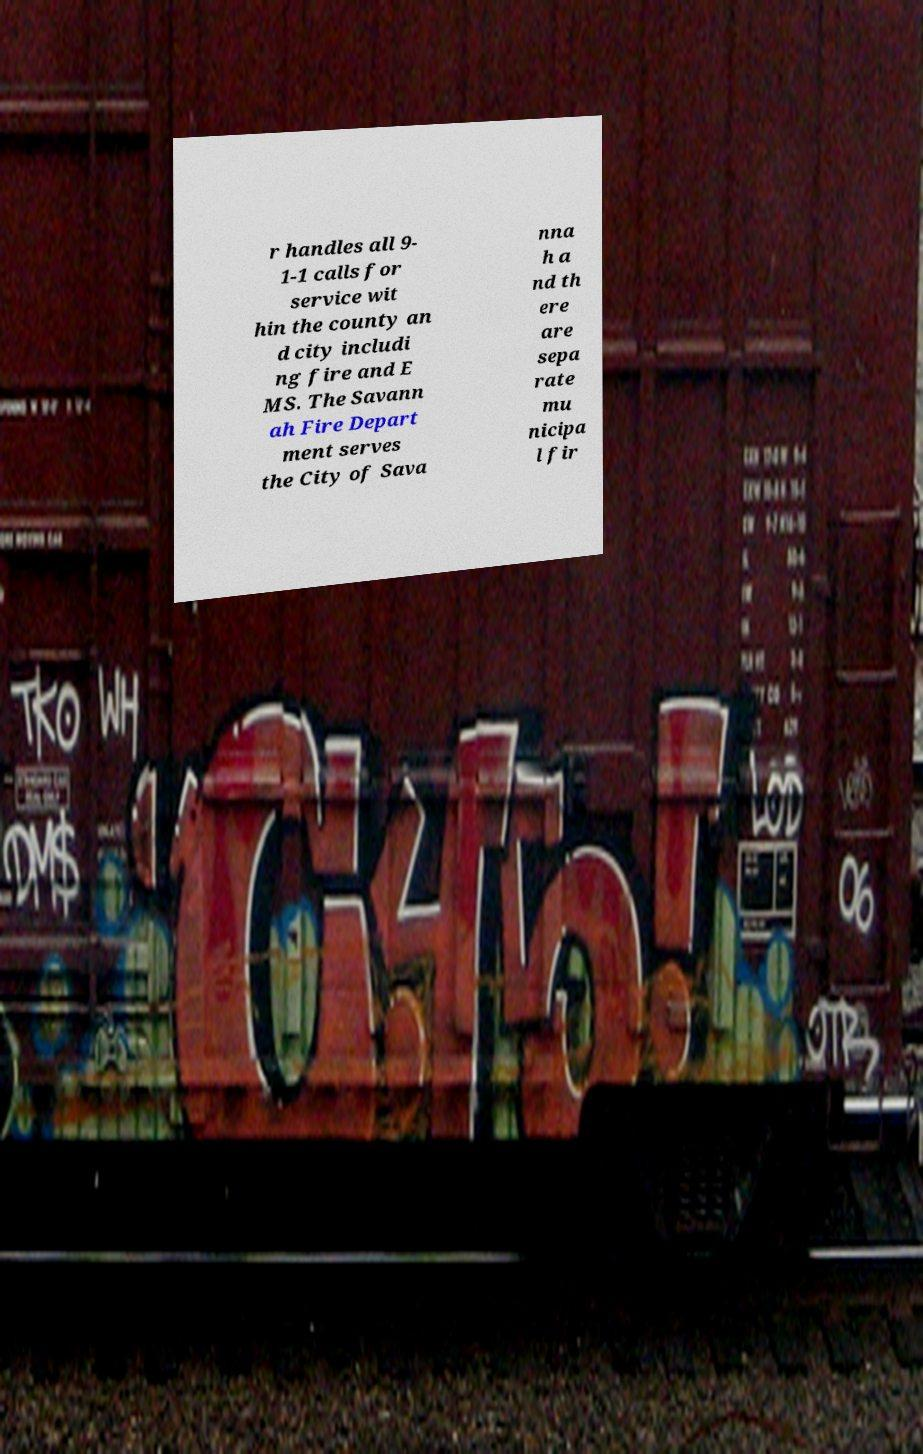Could you assist in decoding the text presented in this image and type it out clearly? r handles all 9- 1-1 calls for service wit hin the county an d city includi ng fire and E MS. The Savann ah Fire Depart ment serves the City of Sava nna h a nd th ere are sepa rate mu nicipa l fir 